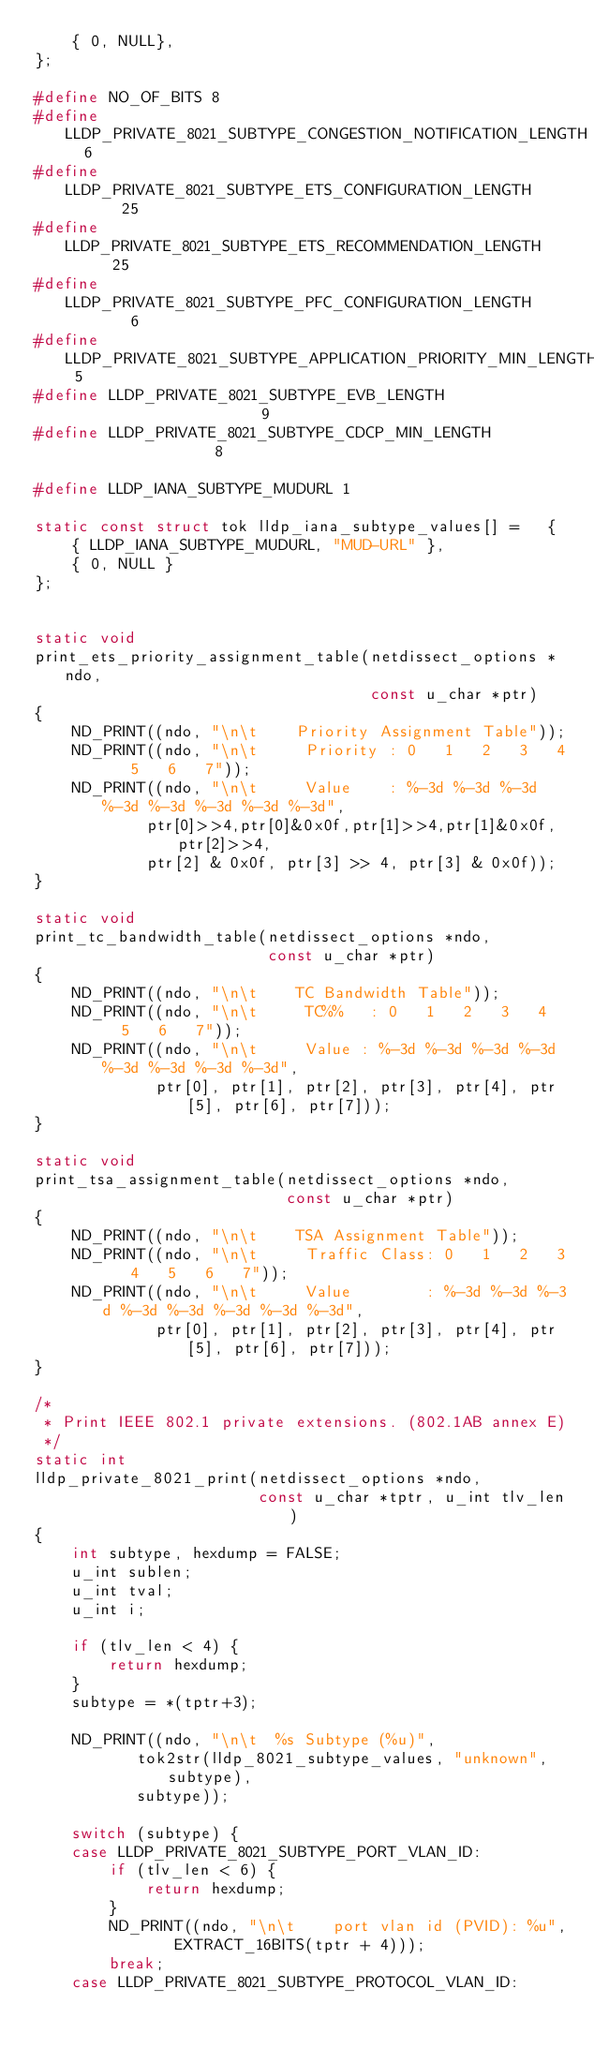<code> <loc_0><loc_0><loc_500><loc_500><_C_>    { 0, NULL},
};

#define NO_OF_BITS 8
#define LLDP_PRIVATE_8021_SUBTYPE_CONGESTION_NOTIFICATION_LENGTH  6
#define LLDP_PRIVATE_8021_SUBTYPE_ETS_CONFIGURATION_LENGTH       25
#define LLDP_PRIVATE_8021_SUBTYPE_ETS_RECOMMENDATION_LENGTH      25
#define LLDP_PRIVATE_8021_SUBTYPE_PFC_CONFIGURATION_LENGTH        6
#define LLDP_PRIVATE_8021_SUBTYPE_APPLICATION_PRIORITY_MIN_LENGTH 5
#define LLDP_PRIVATE_8021_SUBTYPE_EVB_LENGTH                      9
#define LLDP_PRIVATE_8021_SUBTYPE_CDCP_MIN_LENGTH                 8

#define LLDP_IANA_SUBTYPE_MUDURL 1

static const struct tok lldp_iana_subtype_values[] =   {
    { LLDP_IANA_SUBTYPE_MUDURL, "MUD-URL" },
    { 0, NULL }
};


static void
print_ets_priority_assignment_table(netdissect_options *ndo,
                                    const u_char *ptr)
{
    ND_PRINT((ndo, "\n\t    Priority Assignment Table"));
    ND_PRINT((ndo, "\n\t     Priority : 0   1   2   3   4   5   6   7"));
    ND_PRINT((ndo, "\n\t     Value    : %-3d %-3d %-3d %-3d %-3d %-3d %-3d %-3d",
            ptr[0]>>4,ptr[0]&0x0f,ptr[1]>>4,ptr[1]&0x0f,ptr[2]>>4,
            ptr[2] & 0x0f, ptr[3] >> 4, ptr[3] & 0x0f));
}

static void
print_tc_bandwidth_table(netdissect_options *ndo,
                         const u_char *ptr)
{
    ND_PRINT((ndo, "\n\t    TC Bandwidth Table"));
    ND_PRINT((ndo, "\n\t     TC%%   : 0   1   2   3   4   5   6   7"));
    ND_PRINT((ndo, "\n\t     Value : %-3d %-3d %-3d %-3d %-3d %-3d %-3d %-3d",
             ptr[0], ptr[1], ptr[2], ptr[3], ptr[4], ptr[5], ptr[6], ptr[7]));
}

static void
print_tsa_assignment_table(netdissect_options *ndo,
                           const u_char *ptr)
{
    ND_PRINT((ndo, "\n\t    TSA Assignment Table"));
    ND_PRINT((ndo, "\n\t     Traffic Class: 0   1   2   3   4   5   6   7"));
    ND_PRINT((ndo, "\n\t     Value        : %-3d %-3d %-3d %-3d %-3d %-3d %-3d %-3d",
             ptr[0], ptr[1], ptr[2], ptr[3], ptr[4], ptr[5], ptr[6], ptr[7]));
}

/*
 * Print IEEE 802.1 private extensions. (802.1AB annex E)
 */
static int
lldp_private_8021_print(netdissect_options *ndo,
                        const u_char *tptr, u_int tlv_len)
{
    int subtype, hexdump = FALSE;
    u_int sublen;
    u_int tval;
    u_int i;

    if (tlv_len < 4) {
        return hexdump;
    }
    subtype = *(tptr+3);

    ND_PRINT((ndo, "\n\t  %s Subtype (%u)",
           tok2str(lldp_8021_subtype_values, "unknown", subtype),
           subtype));

    switch (subtype) {
    case LLDP_PRIVATE_8021_SUBTYPE_PORT_VLAN_ID:
        if (tlv_len < 6) {
            return hexdump;
        }
        ND_PRINT((ndo, "\n\t    port vlan id (PVID): %u",
               EXTRACT_16BITS(tptr + 4)));
        break;
    case LLDP_PRIVATE_8021_SUBTYPE_PROTOCOL_VLAN_ID:</code> 